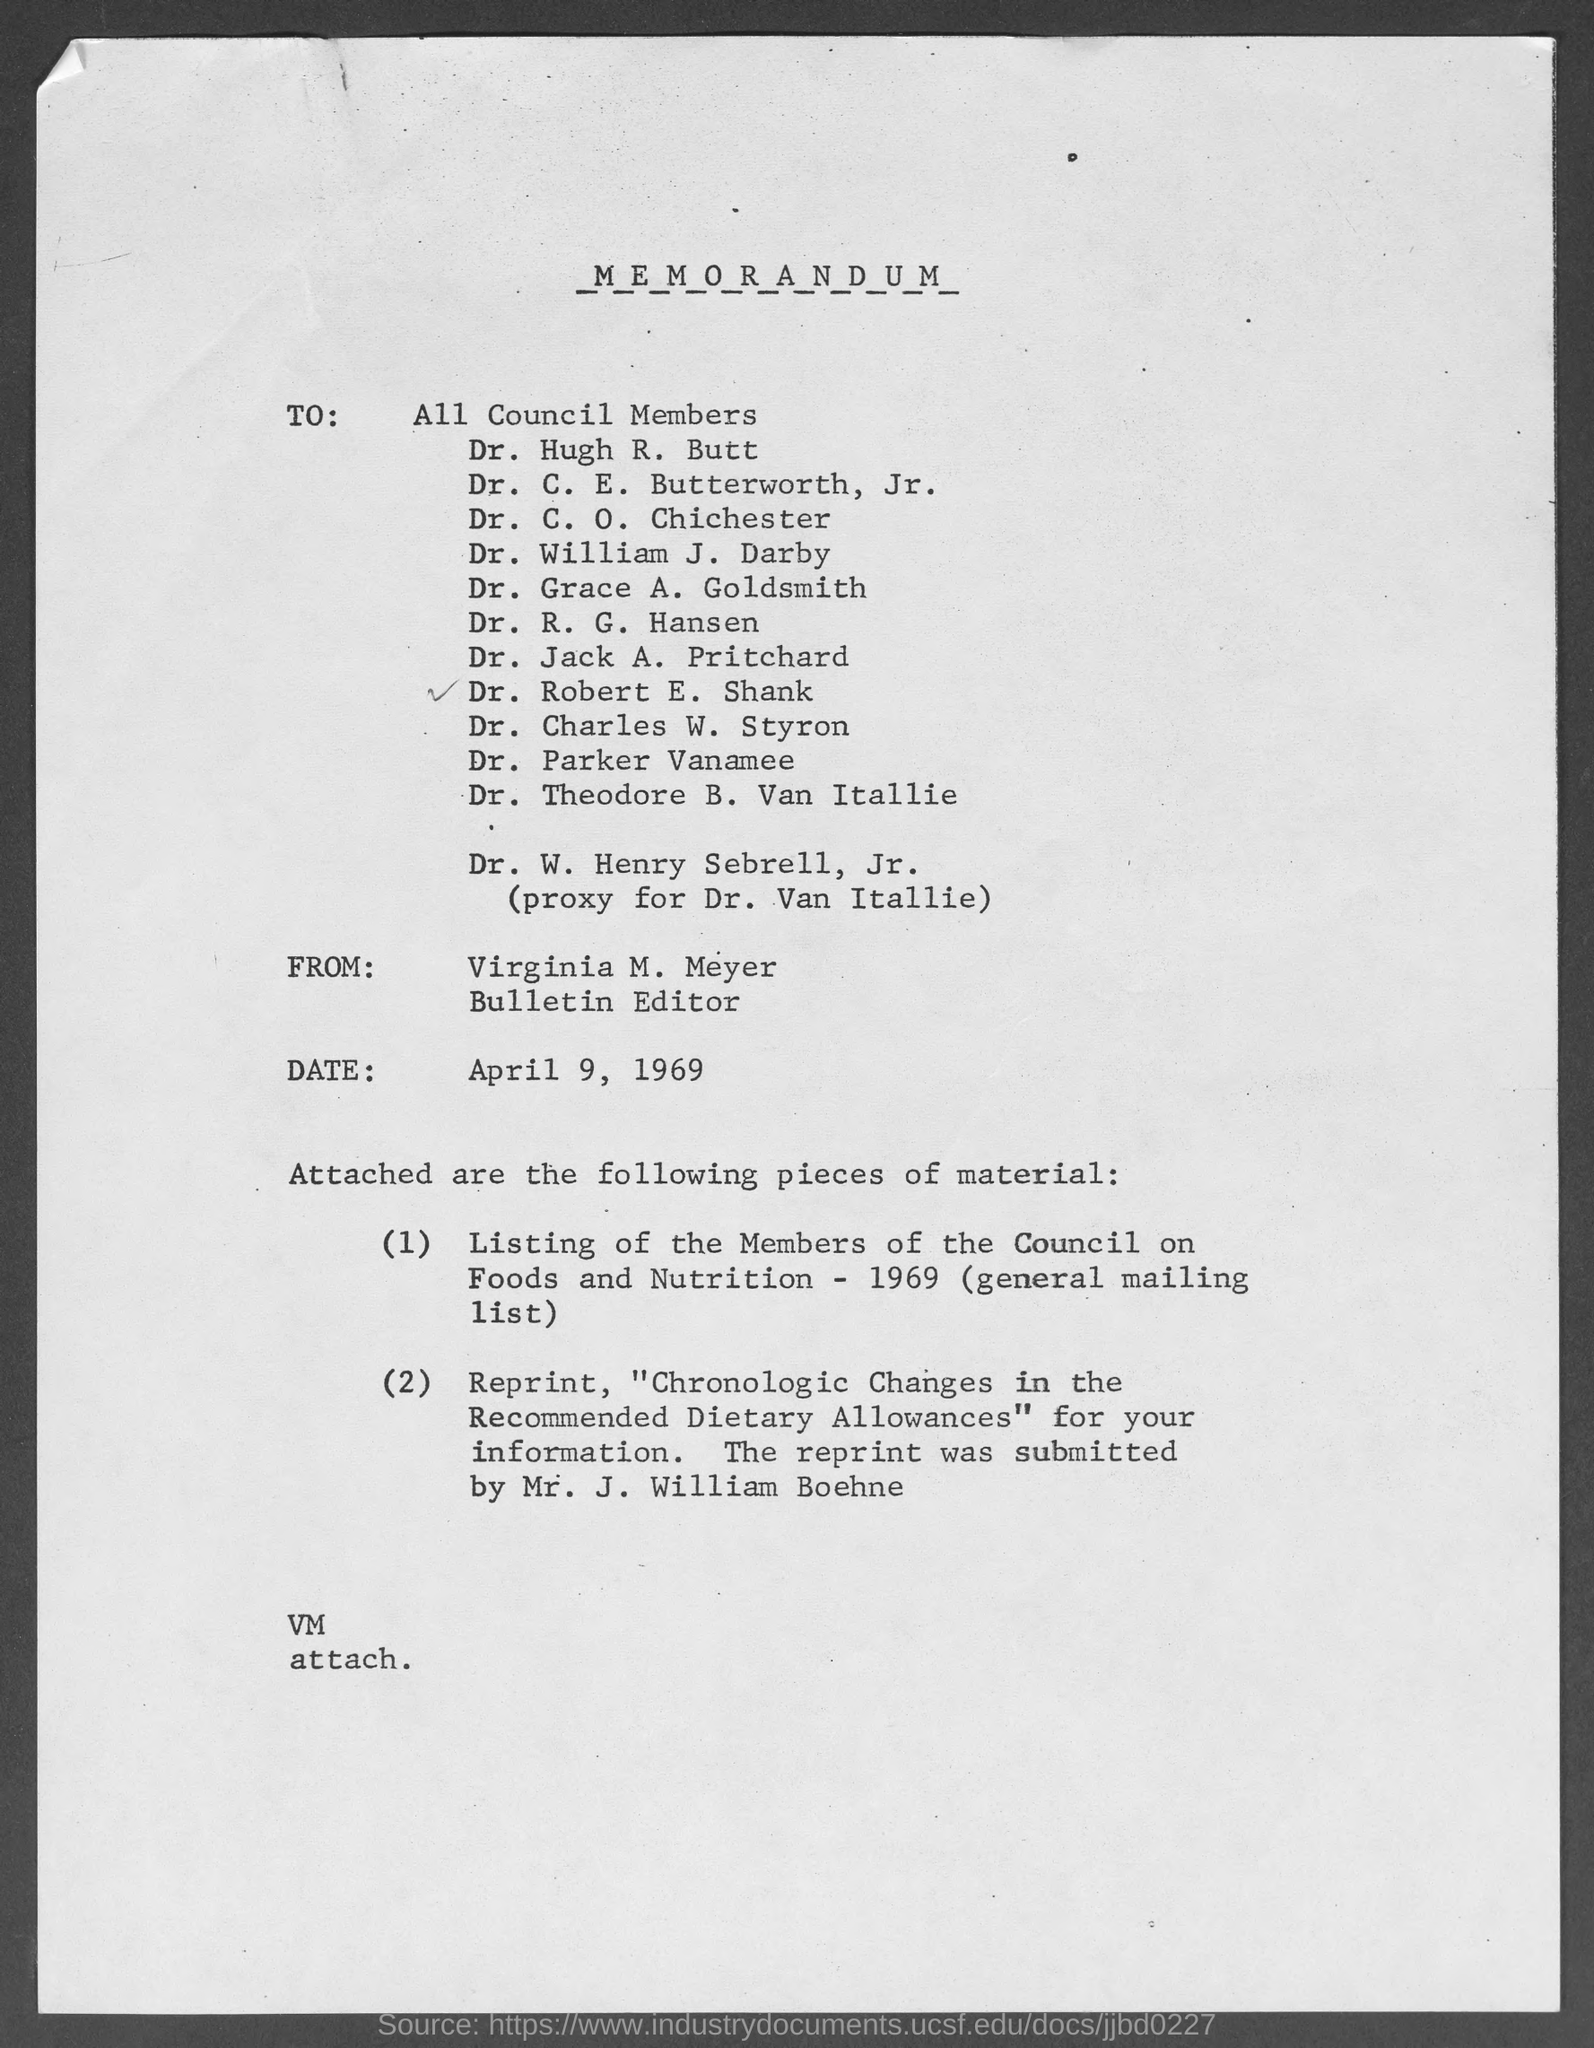What is the from address in memorandum ?
Your answer should be compact. Virginia M. Meyer. When is the memorandum dated?
Your answer should be compact. April 9, 1969. 